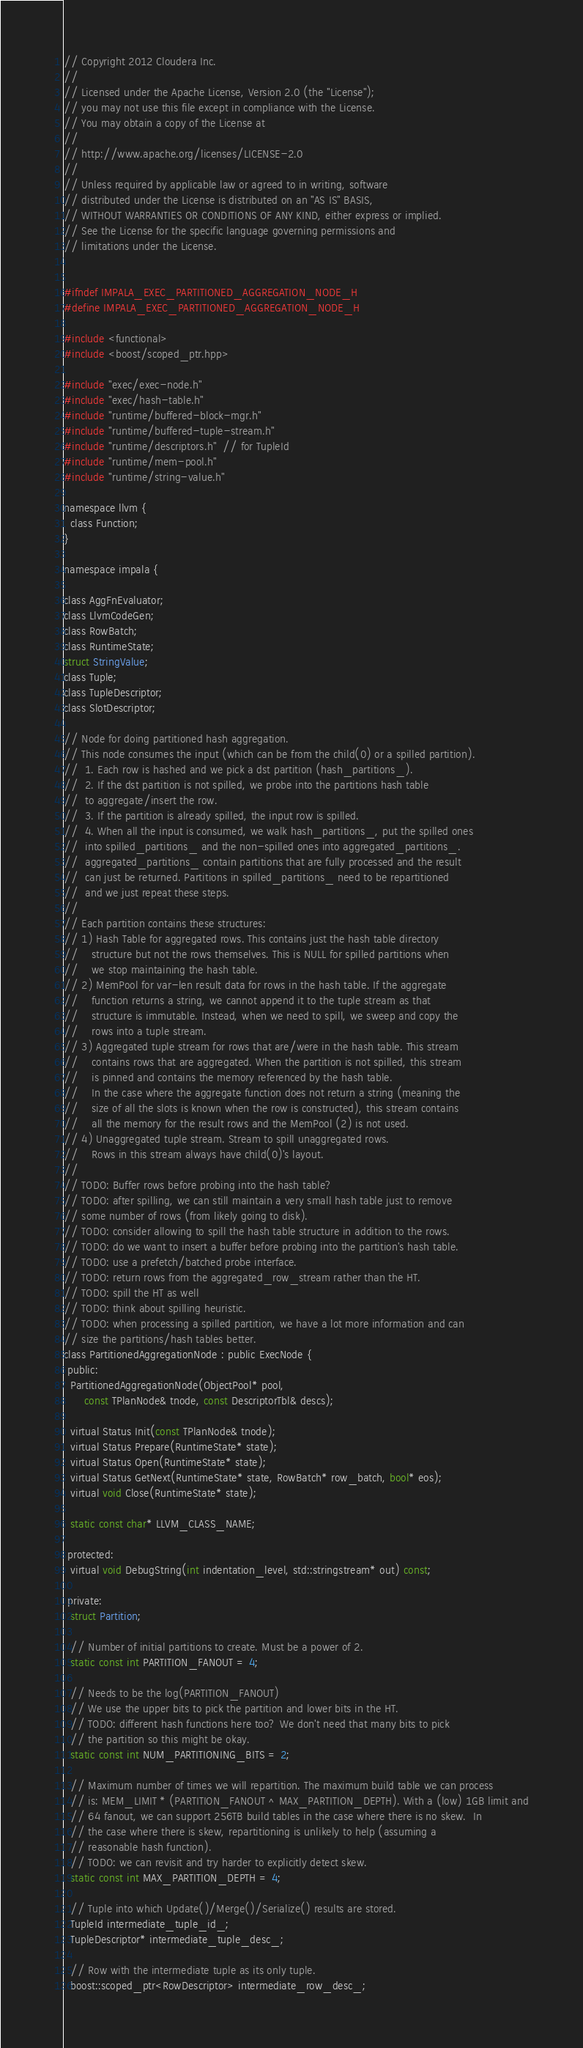Convert code to text. <code><loc_0><loc_0><loc_500><loc_500><_C_>// Copyright 2012 Cloudera Inc.
//
// Licensed under the Apache License, Version 2.0 (the "License");
// you may not use this file except in compliance with the License.
// You may obtain a copy of the License at
//
// http://www.apache.org/licenses/LICENSE-2.0
//
// Unless required by applicable law or agreed to in writing, software
// distributed under the License is distributed on an "AS IS" BASIS,
// WITHOUT WARRANTIES OR CONDITIONS OF ANY KIND, either express or implied.
// See the License for the specific language governing permissions and
// limitations under the License.


#ifndef IMPALA_EXEC_PARTITIONED_AGGREGATION_NODE_H
#define IMPALA_EXEC_PARTITIONED_AGGREGATION_NODE_H

#include <functional>
#include <boost/scoped_ptr.hpp>

#include "exec/exec-node.h"
#include "exec/hash-table.h"
#include "runtime/buffered-block-mgr.h"
#include "runtime/buffered-tuple-stream.h"
#include "runtime/descriptors.h"  // for TupleId
#include "runtime/mem-pool.h"
#include "runtime/string-value.h"

namespace llvm {
  class Function;
}

namespace impala {

class AggFnEvaluator;
class LlvmCodeGen;
class RowBatch;
class RuntimeState;
struct StringValue;
class Tuple;
class TupleDescriptor;
class SlotDescriptor;

// Node for doing partitioned hash aggregation.
// This node consumes the input (which can be from the child(0) or a spilled partition).
//  1. Each row is hashed and we pick a dst partition (hash_partitions_).
//  2. If the dst partition is not spilled, we probe into the partitions hash table
//  to aggregate/insert the row.
//  3. If the partition is already spilled, the input row is spilled.
//  4. When all the input is consumed, we walk hash_partitions_, put the spilled ones
//  into spilled_partitions_ and the non-spilled ones into aggregated_partitions_.
//  aggregated_partitions_ contain partitions that are fully processed and the result
//  can just be returned. Partitions in spilled_partitions_ need to be repartitioned
//  and we just repeat these steps.
//
// Each partition contains these structures:
// 1) Hash Table for aggregated rows. This contains just the hash table directory
//    structure but not the rows themselves. This is NULL for spilled partitions when
//    we stop maintaining the hash table.
// 2) MemPool for var-len result data for rows in the hash table. If the aggregate
//    function returns a string, we cannot append it to the tuple stream as that
//    structure is immutable. Instead, when we need to spill, we sweep and copy the
//    rows into a tuple stream.
// 3) Aggregated tuple stream for rows that are/were in the hash table. This stream
//    contains rows that are aggregated. When the partition is not spilled, this stream
//    is pinned and contains the memory referenced by the hash table.
//    In the case where the aggregate function does not return a string (meaning the
//    size of all the slots is known when the row is constructed), this stream contains
//    all the memory for the result rows and the MemPool (2) is not used.
// 4) Unaggregated tuple stream. Stream to spill unaggregated rows.
//    Rows in this stream always have child(0)'s layout.
//
// TODO: Buffer rows before probing into the hash table?
// TODO: after spilling, we can still maintain a very small hash table just to remove
// some number of rows (from likely going to disk).
// TODO: consider allowing to spill the hash table structure in addition to the rows.
// TODO: do we want to insert a buffer before probing into the partition's hash table.
// TODO: use a prefetch/batched probe interface.
// TODO: return rows from the aggregated_row_stream rather than the HT.
// TODO: spill the HT as well
// TODO: think about spilling heuristic.
// TODO: when processing a spilled partition, we have a lot more information and can
// size the partitions/hash tables better.
class PartitionedAggregationNode : public ExecNode {
 public:
  PartitionedAggregationNode(ObjectPool* pool,
      const TPlanNode& tnode, const DescriptorTbl& descs);

  virtual Status Init(const TPlanNode& tnode);
  virtual Status Prepare(RuntimeState* state);
  virtual Status Open(RuntimeState* state);
  virtual Status GetNext(RuntimeState* state, RowBatch* row_batch, bool* eos);
  virtual void Close(RuntimeState* state);

  static const char* LLVM_CLASS_NAME;

 protected:
  virtual void DebugString(int indentation_level, std::stringstream* out) const;

 private:
  struct Partition;

  // Number of initial partitions to create. Must be a power of 2.
  static const int PARTITION_FANOUT = 4;

  // Needs to be the log(PARTITION_FANOUT)
  // We use the upper bits to pick the partition and lower bits in the HT.
  // TODO: different hash functions here too? We don't need that many bits to pick
  // the partition so this might be okay.
  static const int NUM_PARTITIONING_BITS = 2;

  // Maximum number of times we will repartition. The maximum build table we can process
  // is: MEM_LIMIT * (PARTITION_FANOUT ^ MAX_PARTITION_DEPTH). With a (low) 1GB limit and
  // 64 fanout, we can support 256TB build tables in the case where there is no skew.  In
  // the case where there is skew, repartitioning is unlikely to help (assuming a
  // reasonable hash function).
  // TODO: we can revisit and try harder to explicitly detect skew.
  static const int MAX_PARTITION_DEPTH = 4;

  // Tuple into which Update()/Merge()/Serialize() results are stored.
  TupleId intermediate_tuple_id_;
  TupleDescriptor* intermediate_tuple_desc_;

  // Row with the intermediate tuple as its only tuple.
  boost::scoped_ptr<RowDescriptor> intermediate_row_desc_;
</code> 